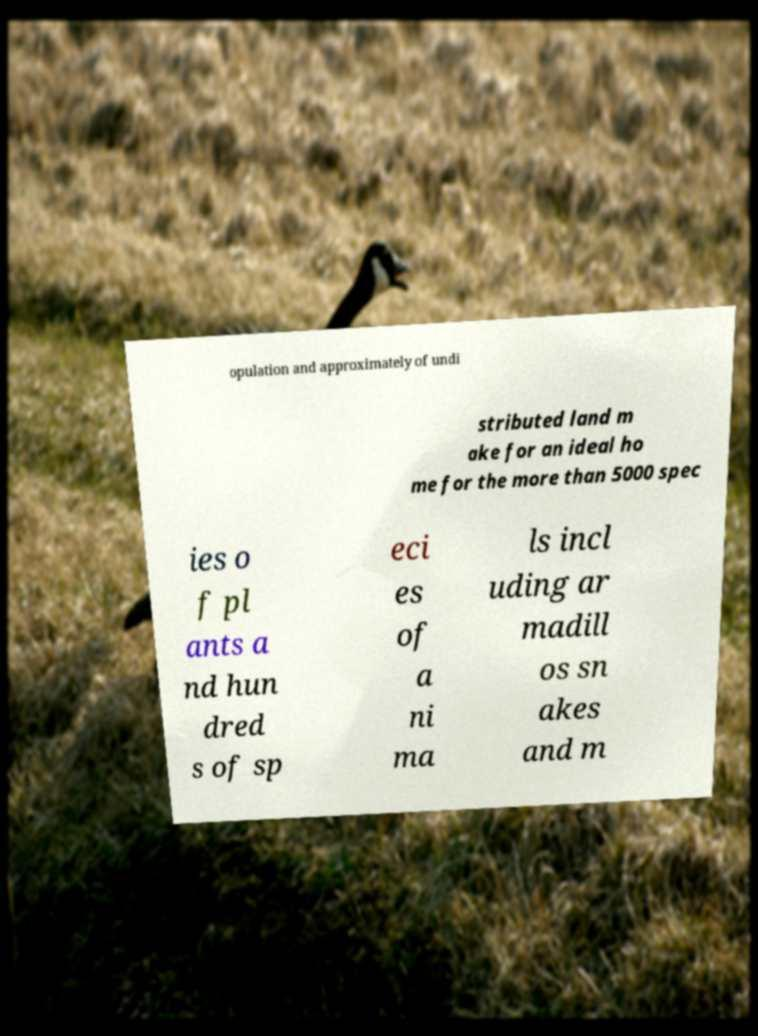I need the written content from this picture converted into text. Can you do that? opulation and approximately of undi stributed land m ake for an ideal ho me for the more than 5000 spec ies o f pl ants a nd hun dred s of sp eci es of a ni ma ls incl uding ar madill os sn akes and m 